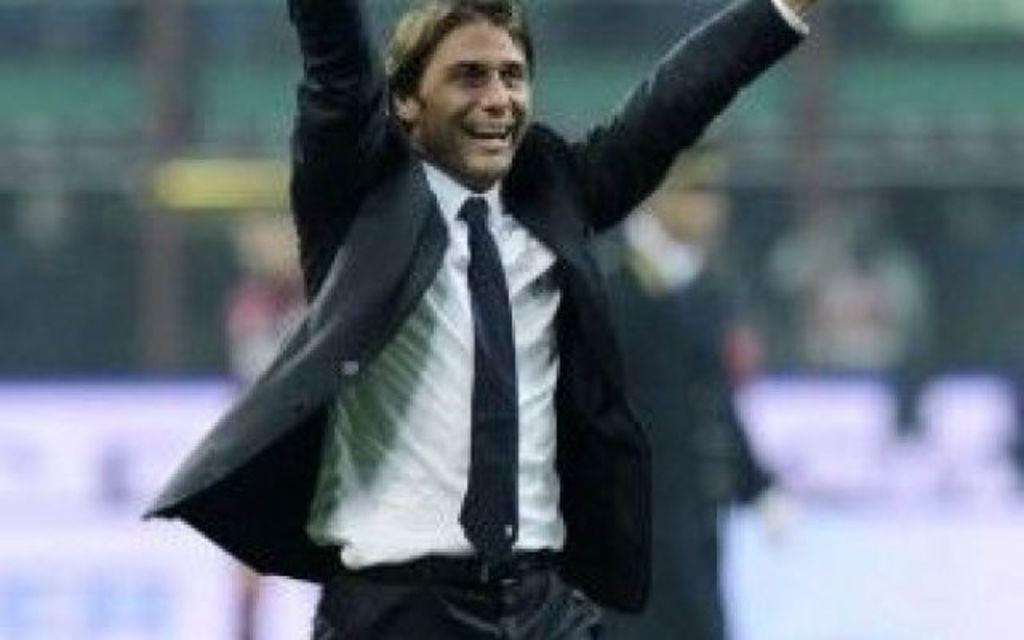What is the main subject of the image? There is a man standing in the image. What is the man's facial expression? The man is smiling. What is the man wearing in the image? The man is wearing a suit. How would you describe the background of the image? The background of the image is blurry. What type of feast is being prepared in the background of the image? There is no feast or any indication of food preparation in the image; it primarily features a man standing and smiling. 